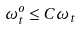<formula> <loc_0><loc_0><loc_500><loc_500>\omega _ { t } ^ { o } \leq C \omega _ { t }</formula> 